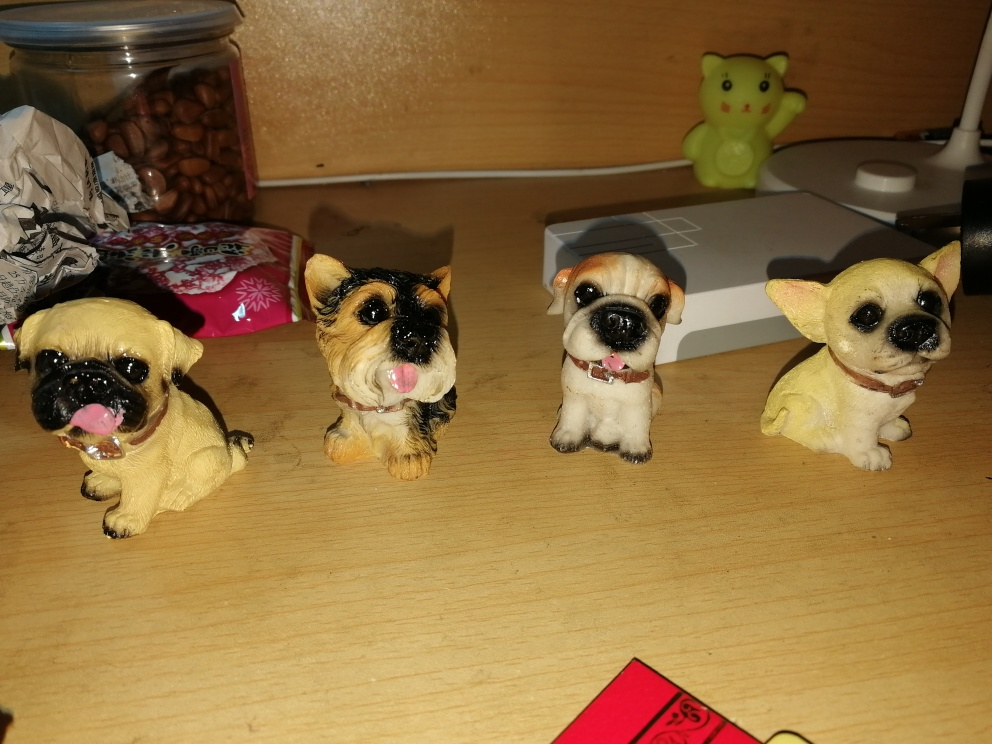What can be seen as the subject in this image?
 a dog 